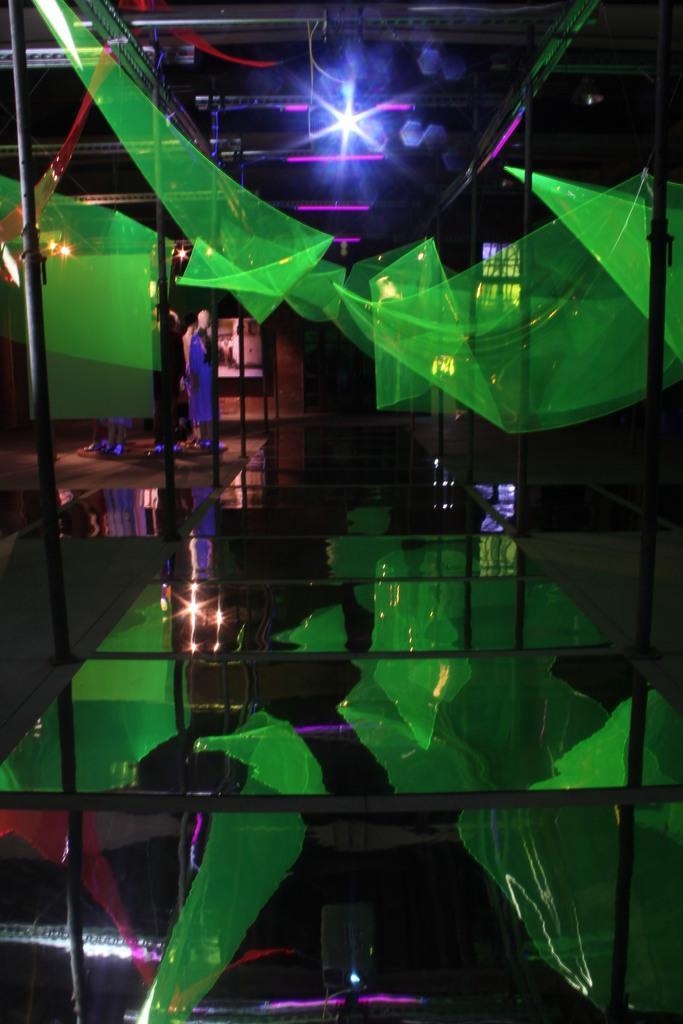Please provide a concise description of this image. In this image, we can see mannequins, poles, lights and green objects. Here we can see glass floor. On the glass floor, we can see reflections. 